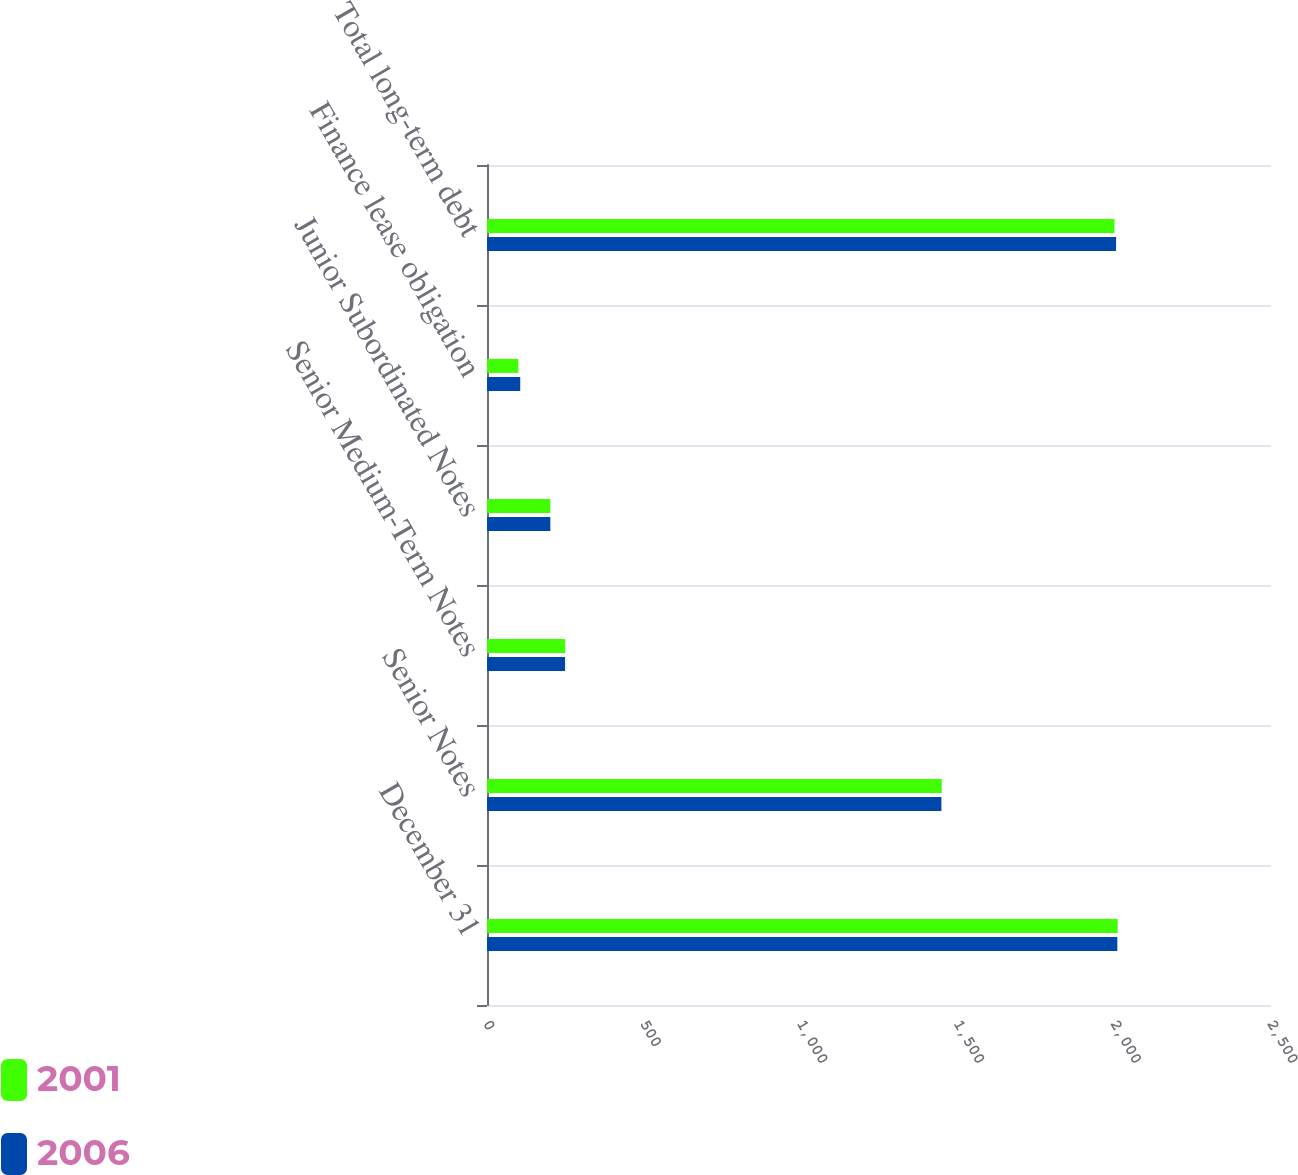<chart> <loc_0><loc_0><loc_500><loc_500><stacked_bar_chart><ecel><fcel>December 31<fcel>Senior Notes<fcel>Senior Medium-Term Notes<fcel>Junior Subordinated Notes<fcel>Finance lease obligation<fcel>Total long-term debt<nl><fcel>2001<fcel>2011<fcel>1450<fcel>249<fcel>202<fcel>100<fcel>2001<nl><fcel>2006<fcel>2010<fcel>1449<fcel>249<fcel>202<fcel>106<fcel>2006<nl></chart> 